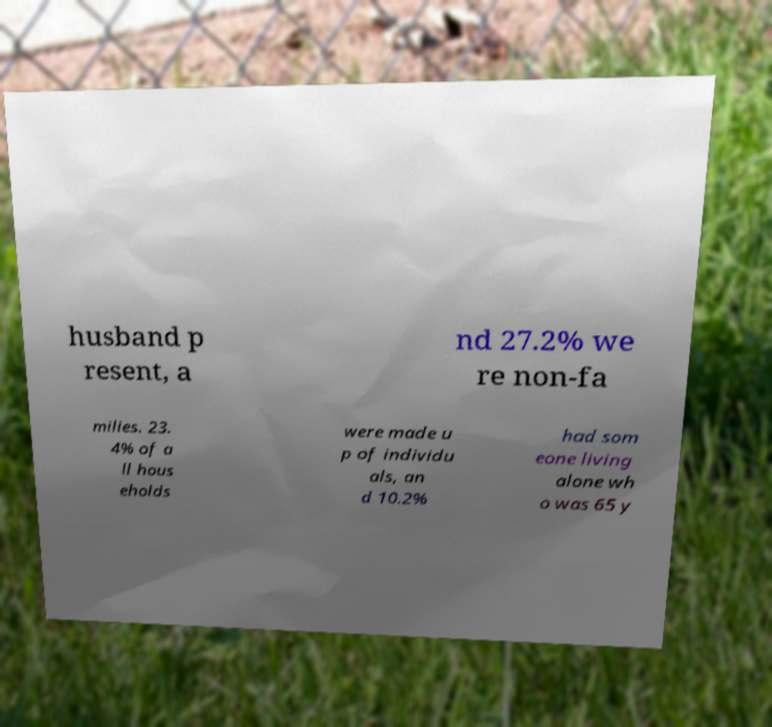Please identify and transcribe the text found in this image. husband p resent, a nd 27.2% we re non-fa milies. 23. 4% of a ll hous eholds were made u p of individu als, an d 10.2% had som eone living alone wh o was 65 y 